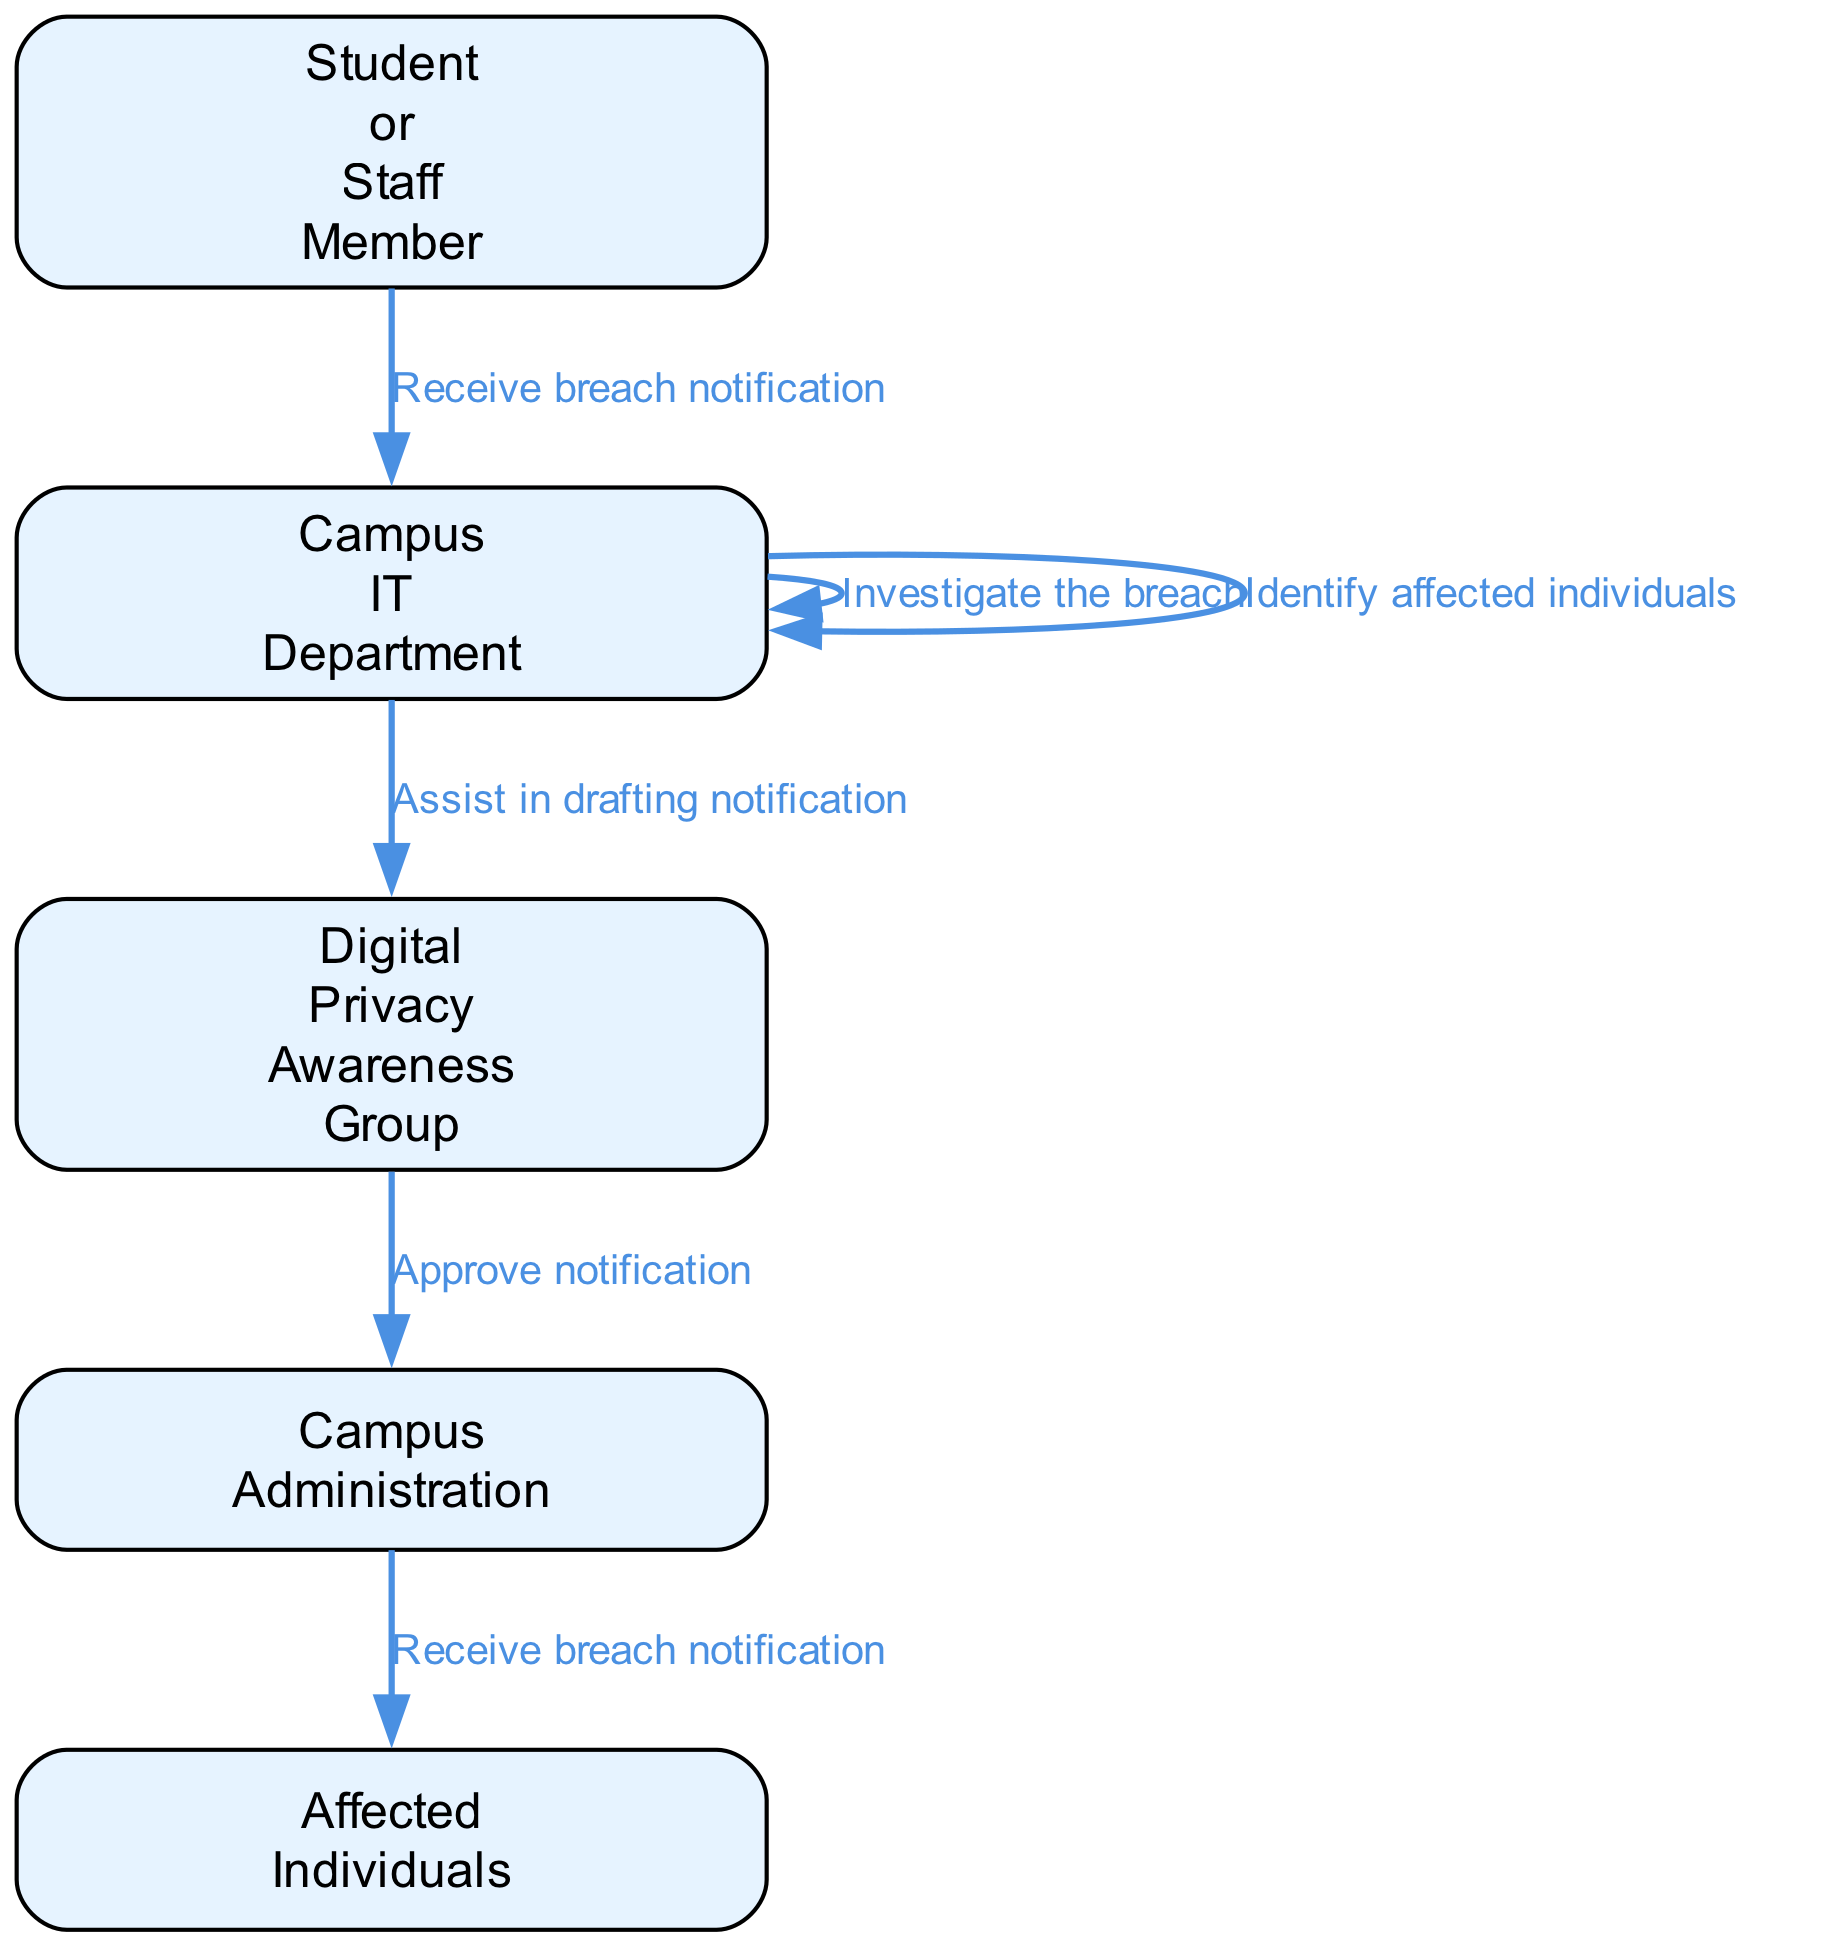What action does the Student or Staff Member take first? The diagram shows that the first action taken by the Student or Staff Member is to discover a potential data breach. This is the initial step in the sequence.
Answer: Discover potential data breach How many total steps are involved in reporting a data breach? By counting the unique actions represented in the diagram, there are a total of 7 steps involved in the process of reporting a data breach, starting from the discovery to the receiving of notifications by affected individuals.
Answer: 7 Who prepares the notification? According to the sequence, the Campus IT Department is the entity responsible for preparing the notification after identifying affected individuals. This is a specific action documented in the flow.
Answer: Prepare notification What is the last action in the sequence? The last action in the sequence indicates that affected individuals receive the breach notification and follow the guidance provided for protection, marking the conclusion of the reporting process.
Answer: Follow guidance for protection Which group assists in drafting the notification? The diagram clearly indicates that the Digital Privacy Awareness Group assists in drafting the notification as part of the sequence, which is crucial for ensuring the communication is accurate and effective.
Answer: Digital Privacy Awareness Group What does Campus Administration do after the notification is approved? After the Campus Administration approves the notification, their next action is to distribute the notification to affected individuals. This step follows directly after the approval.
Answer: Distribute notification to affected individuals Which department investigates the breach? The Campus IT Department is responsible for investigating the breach, as indicated in the sequence. This step is crucial for understanding the implications and details of the data breach.
Answer: Campus IT Department How does the sequence flow from the Campus IT Department? The sequence flows from the Campus IT Department first receiving the breach notification, then assessing it, investigating the details, determining the extent, and finally identifying affected individuals before preparing the notification. This illustrates a systematic approach to handling the breach.
Answer: Assess the breach → Investigate the breach → Determine the extent of the breach → Identify affected individuals 